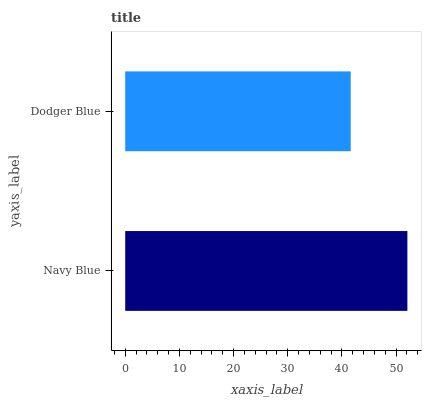Is Dodger Blue the minimum?
Answer yes or no. Yes. Is Navy Blue the maximum?
Answer yes or no. Yes. Is Dodger Blue the maximum?
Answer yes or no. No. Is Navy Blue greater than Dodger Blue?
Answer yes or no. Yes. Is Dodger Blue less than Navy Blue?
Answer yes or no. Yes. Is Dodger Blue greater than Navy Blue?
Answer yes or no. No. Is Navy Blue less than Dodger Blue?
Answer yes or no. No. Is Navy Blue the high median?
Answer yes or no. Yes. Is Dodger Blue the low median?
Answer yes or no. Yes. Is Dodger Blue the high median?
Answer yes or no. No. Is Navy Blue the low median?
Answer yes or no. No. 